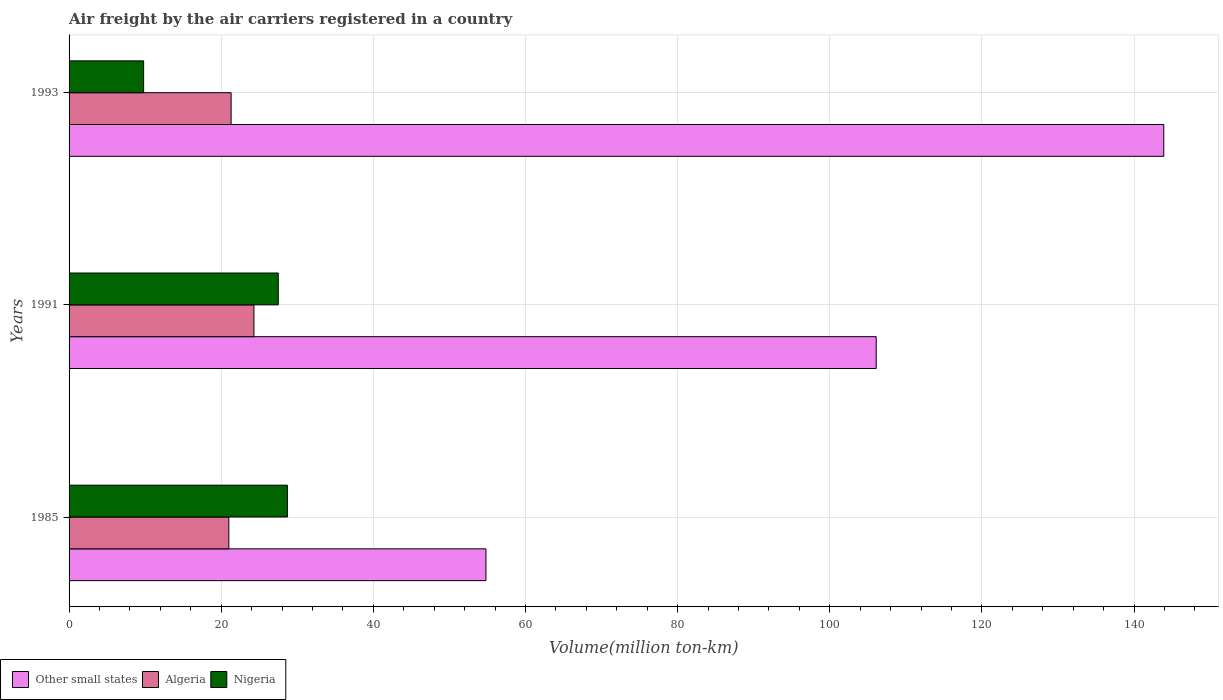How many different coloured bars are there?
Offer a very short reply. 3. Are the number of bars on each tick of the Y-axis equal?
Offer a very short reply. Yes. How many bars are there on the 2nd tick from the top?
Your answer should be compact. 3. What is the volume of the air carriers in Other small states in 1993?
Keep it short and to the point. 143.9. Across all years, what is the maximum volume of the air carriers in Other small states?
Your answer should be very brief. 143.9. In which year was the volume of the air carriers in Other small states minimum?
Make the answer very short. 1985. What is the total volume of the air carriers in Nigeria in the graph?
Ensure brevity in your answer.  66. What is the difference between the volume of the air carriers in Algeria in 1985 and that in 1993?
Provide a succinct answer. -0.3. What is the difference between the volume of the air carriers in Other small states in 1993 and the volume of the air carriers in Algeria in 1991?
Ensure brevity in your answer.  119.6. What is the average volume of the air carriers in Algeria per year?
Your response must be concise. 22.2. In the year 1991, what is the difference between the volume of the air carriers in Other small states and volume of the air carriers in Algeria?
Your response must be concise. 81.8. What is the ratio of the volume of the air carriers in Nigeria in 1985 to that in 1991?
Keep it short and to the point. 1.04. Is the difference between the volume of the air carriers in Other small states in 1985 and 1991 greater than the difference between the volume of the air carriers in Algeria in 1985 and 1991?
Provide a short and direct response. No. What is the difference between the highest and the second highest volume of the air carriers in Algeria?
Your answer should be compact. 3. What is the difference between the highest and the lowest volume of the air carriers in Other small states?
Keep it short and to the point. 89.1. What does the 2nd bar from the top in 1985 represents?
Keep it short and to the point. Algeria. What does the 1st bar from the bottom in 1991 represents?
Keep it short and to the point. Other small states. How many bars are there?
Provide a short and direct response. 9. How many years are there in the graph?
Provide a succinct answer. 3. Are the values on the major ticks of X-axis written in scientific E-notation?
Make the answer very short. No. Does the graph contain grids?
Keep it short and to the point. Yes. How are the legend labels stacked?
Provide a succinct answer. Horizontal. What is the title of the graph?
Provide a short and direct response. Air freight by the air carriers registered in a country. Does "Uzbekistan" appear as one of the legend labels in the graph?
Offer a terse response. No. What is the label or title of the X-axis?
Keep it short and to the point. Volume(million ton-km). What is the Volume(million ton-km) of Other small states in 1985?
Your answer should be compact. 54.8. What is the Volume(million ton-km) of Algeria in 1985?
Your answer should be compact. 21. What is the Volume(million ton-km) of Nigeria in 1985?
Ensure brevity in your answer.  28.7. What is the Volume(million ton-km) in Other small states in 1991?
Offer a terse response. 106.1. What is the Volume(million ton-km) in Algeria in 1991?
Your response must be concise. 24.3. What is the Volume(million ton-km) in Other small states in 1993?
Make the answer very short. 143.9. What is the Volume(million ton-km) of Algeria in 1993?
Offer a terse response. 21.3. What is the Volume(million ton-km) in Nigeria in 1993?
Offer a terse response. 9.8. Across all years, what is the maximum Volume(million ton-km) in Other small states?
Offer a very short reply. 143.9. Across all years, what is the maximum Volume(million ton-km) in Algeria?
Keep it short and to the point. 24.3. Across all years, what is the maximum Volume(million ton-km) in Nigeria?
Give a very brief answer. 28.7. Across all years, what is the minimum Volume(million ton-km) of Other small states?
Your response must be concise. 54.8. Across all years, what is the minimum Volume(million ton-km) of Nigeria?
Your answer should be compact. 9.8. What is the total Volume(million ton-km) in Other small states in the graph?
Make the answer very short. 304.8. What is the total Volume(million ton-km) of Algeria in the graph?
Your answer should be very brief. 66.6. What is the total Volume(million ton-km) of Nigeria in the graph?
Make the answer very short. 66. What is the difference between the Volume(million ton-km) in Other small states in 1985 and that in 1991?
Offer a terse response. -51.3. What is the difference between the Volume(million ton-km) of Algeria in 1985 and that in 1991?
Offer a terse response. -3.3. What is the difference between the Volume(million ton-km) in Other small states in 1985 and that in 1993?
Offer a very short reply. -89.1. What is the difference between the Volume(million ton-km) in Algeria in 1985 and that in 1993?
Ensure brevity in your answer.  -0.3. What is the difference between the Volume(million ton-km) of Other small states in 1991 and that in 1993?
Your response must be concise. -37.8. What is the difference between the Volume(million ton-km) in Other small states in 1985 and the Volume(million ton-km) in Algeria in 1991?
Make the answer very short. 30.5. What is the difference between the Volume(million ton-km) in Other small states in 1985 and the Volume(million ton-km) in Nigeria in 1991?
Your answer should be very brief. 27.3. What is the difference between the Volume(million ton-km) of Other small states in 1985 and the Volume(million ton-km) of Algeria in 1993?
Provide a short and direct response. 33.5. What is the difference between the Volume(million ton-km) in Other small states in 1991 and the Volume(million ton-km) in Algeria in 1993?
Offer a terse response. 84.8. What is the difference between the Volume(million ton-km) of Other small states in 1991 and the Volume(million ton-km) of Nigeria in 1993?
Offer a terse response. 96.3. What is the difference between the Volume(million ton-km) in Algeria in 1991 and the Volume(million ton-km) in Nigeria in 1993?
Ensure brevity in your answer.  14.5. What is the average Volume(million ton-km) in Other small states per year?
Ensure brevity in your answer.  101.6. What is the average Volume(million ton-km) of Algeria per year?
Keep it short and to the point. 22.2. In the year 1985, what is the difference between the Volume(million ton-km) in Other small states and Volume(million ton-km) in Algeria?
Keep it short and to the point. 33.8. In the year 1985, what is the difference between the Volume(million ton-km) in Other small states and Volume(million ton-km) in Nigeria?
Ensure brevity in your answer.  26.1. In the year 1985, what is the difference between the Volume(million ton-km) in Algeria and Volume(million ton-km) in Nigeria?
Provide a succinct answer. -7.7. In the year 1991, what is the difference between the Volume(million ton-km) of Other small states and Volume(million ton-km) of Algeria?
Keep it short and to the point. 81.8. In the year 1991, what is the difference between the Volume(million ton-km) in Other small states and Volume(million ton-km) in Nigeria?
Make the answer very short. 78.6. In the year 1991, what is the difference between the Volume(million ton-km) in Algeria and Volume(million ton-km) in Nigeria?
Your response must be concise. -3.2. In the year 1993, what is the difference between the Volume(million ton-km) in Other small states and Volume(million ton-km) in Algeria?
Your response must be concise. 122.6. In the year 1993, what is the difference between the Volume(million ton-km) of Other small states and Volume(million ton-km) of Nigeria?
Provide a succinct answer. 134.1. What is the ratio of the Volume(million ton-km) in Other small states in 1985 to that in 1991?
Provide a succinct answer. 0.52. What is the ratio of the Volume(million ton-km) of Algeria in 1985 to that in 1991?
Make the answer very short. 0.86. What is the ratio of the Volume(million ton-km) in Nigeria in 1985 to that in 1991?
Make the answer very short. 1.04. What is the ratio of the Volume(million ton-km) of Other small states in 1985 to that in 1993?
Your answer should be compact. 0.38. What is the ratio of the Volume(million ton-km) of Algeria in 1985 to that in 1993?
Make the answer very short. 0.99. What is the ratio of the Volume(million ton-km) of Nigeria in 1985 to that in 1993?
Make the answer very short. 2.93. What is the ratio of the Volume(million ton-km) in Other small states in 1991 to that in 1993?
Offer a terse response. 0.74. What is the ratio of the Volume(million ton-km) in Algeria in 1991 to that in 1993?
Offer a terse response. 1.14. What is the ratio of the Volume(million ton-km) of Nigeria in 1991 to that in 1993?
Provide a short and direct response. 2.81. What is the difference between the highest and the second highest Volume(million ton-km) in Other small states?
Give a very brief answer. 37.8. What is the difference between the highest and the second highest Volume(million ton-km) in Nigeria?
Your answer should be very brief. 1.2. What is the difference between the highest and the lowest Volume(million ton-km) in Other small states?
Provide a succinct answer. 89.1. What is the difference between the highest and the lowest Volume(million ton-km) of Algeria?
Your answer should be very brief. 3.3. What is the difference between the highest and the lowest Volume(million ton-km) of Nigeria?
Make the answer very short. 18.9. 